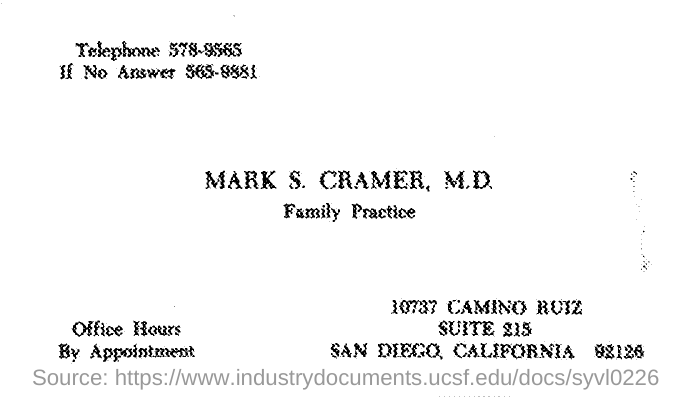Point out several critical features in this image. The individual identified as M.D. of the office is Mark S. Cramer. The telephone number provided is 578-9565. 